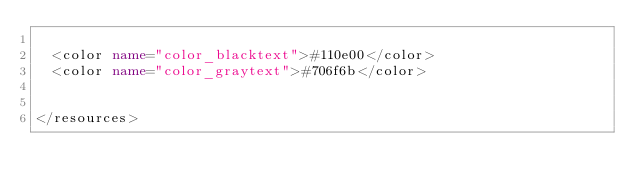<code> <loc_0><loc_0><loc_500><loc_500><_XML_>
  <color name="color_blacktext">#110e00</color>
  <color name="color_graytext">#706f6b</color>
  
  
</resources>
</code> 